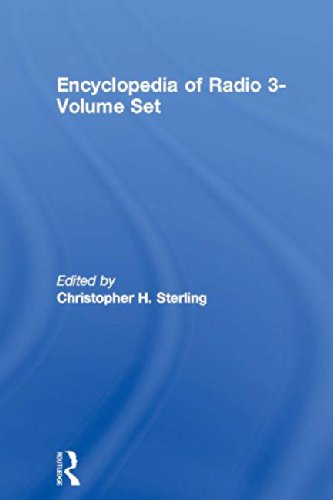Who is the editor mentioned on the cover of this book and what might be his contribution to this field? The editor named on the cover is Christopher H. Sterling. He is known for his extensive research in communication studies and possibly contributed to this encyclopedia by compiling and overseeing the inclusion of authoritative and comprehensive information about radio. 